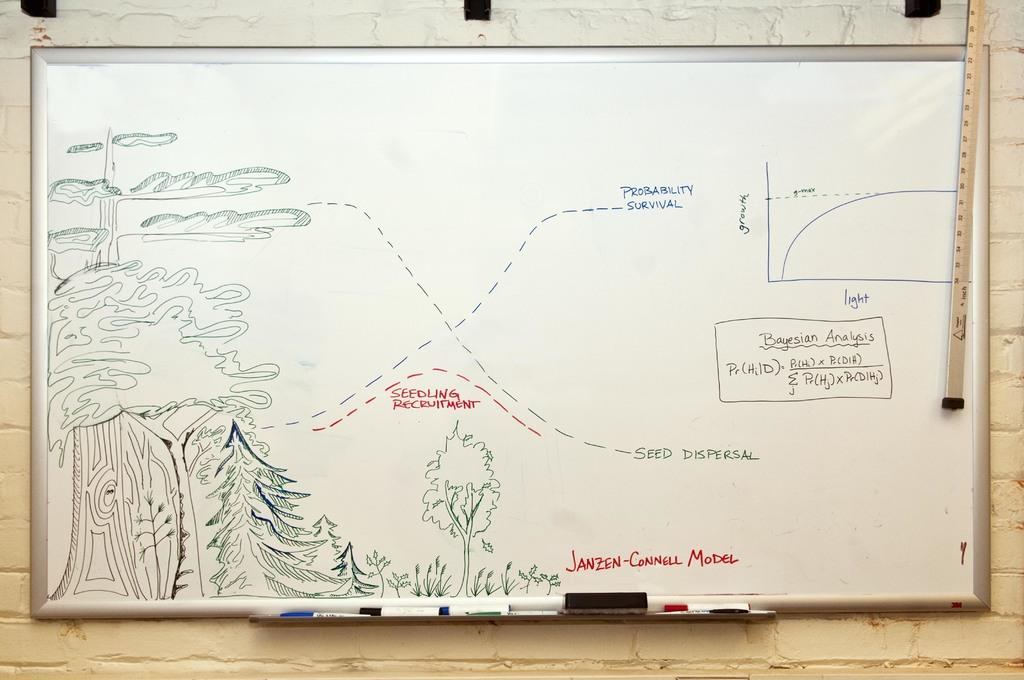Provide a one-sentence caption for the provided image. Seedling recruitment is an area in the middle of the map. 